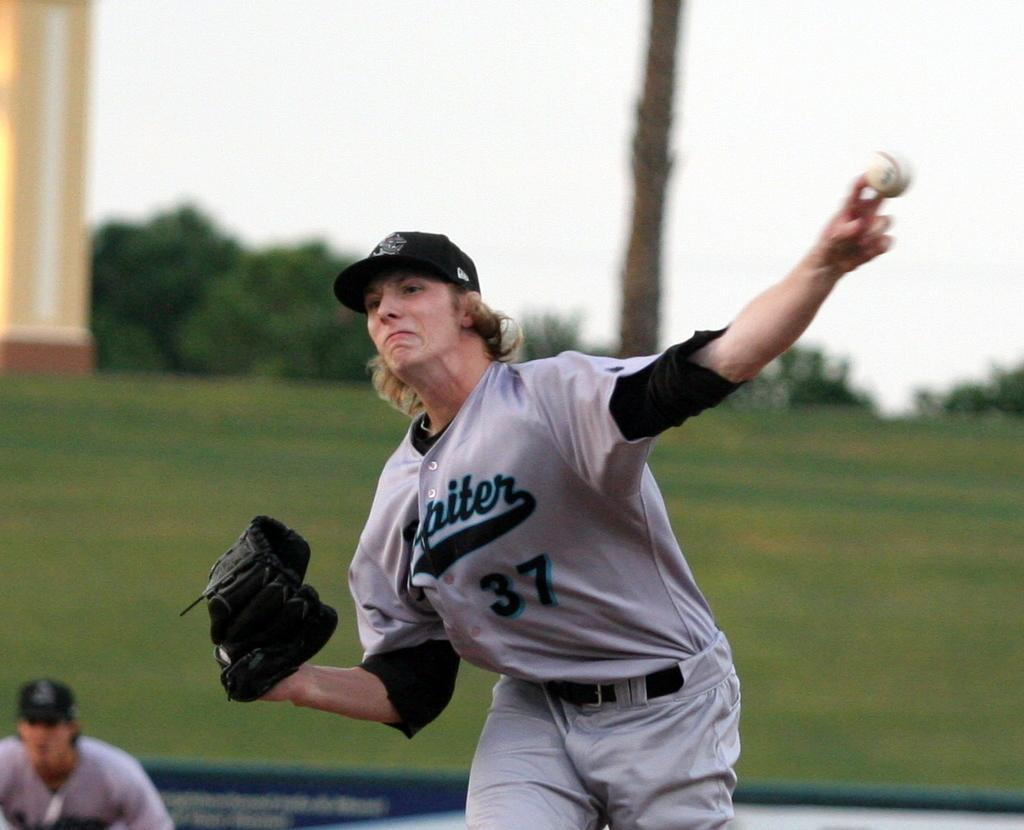<image>
Offer a succinct explanation of the picture presented. A player wearing number 37 plays for the Jupiter team. 